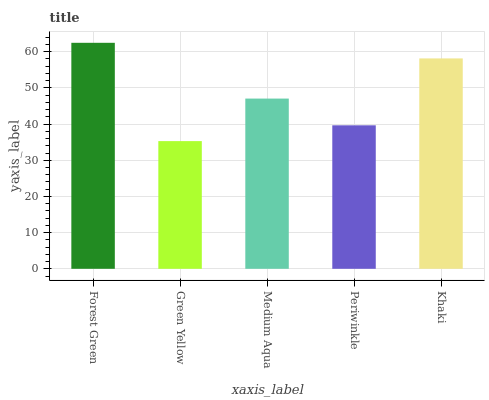Is Medium Aqua the minimum?
Answer yes or no. No. Is Medium Aqua the maximum?
Answer yes or no. No. Is Medium Aqua greater than Green Yellow?
Answer yes or no. Yes. Is Green Yellow less than Medium Aqua?
Answer yes or no. Yes. Is Green Yellow greater than Medium Aqua?
Answer yes or no. No. Is Medium Aqua less than Green Yellow?
Answer yes or no. No. Is Medium Aqua the high median?
Answer yes or no. Yes. Is Medium Aqua the low median?
Answer yes or no. Yes. Is Forest Green the high median?
Answer yes or no. No. Is Periwinkle the low median?
Answer yes or no. No. 